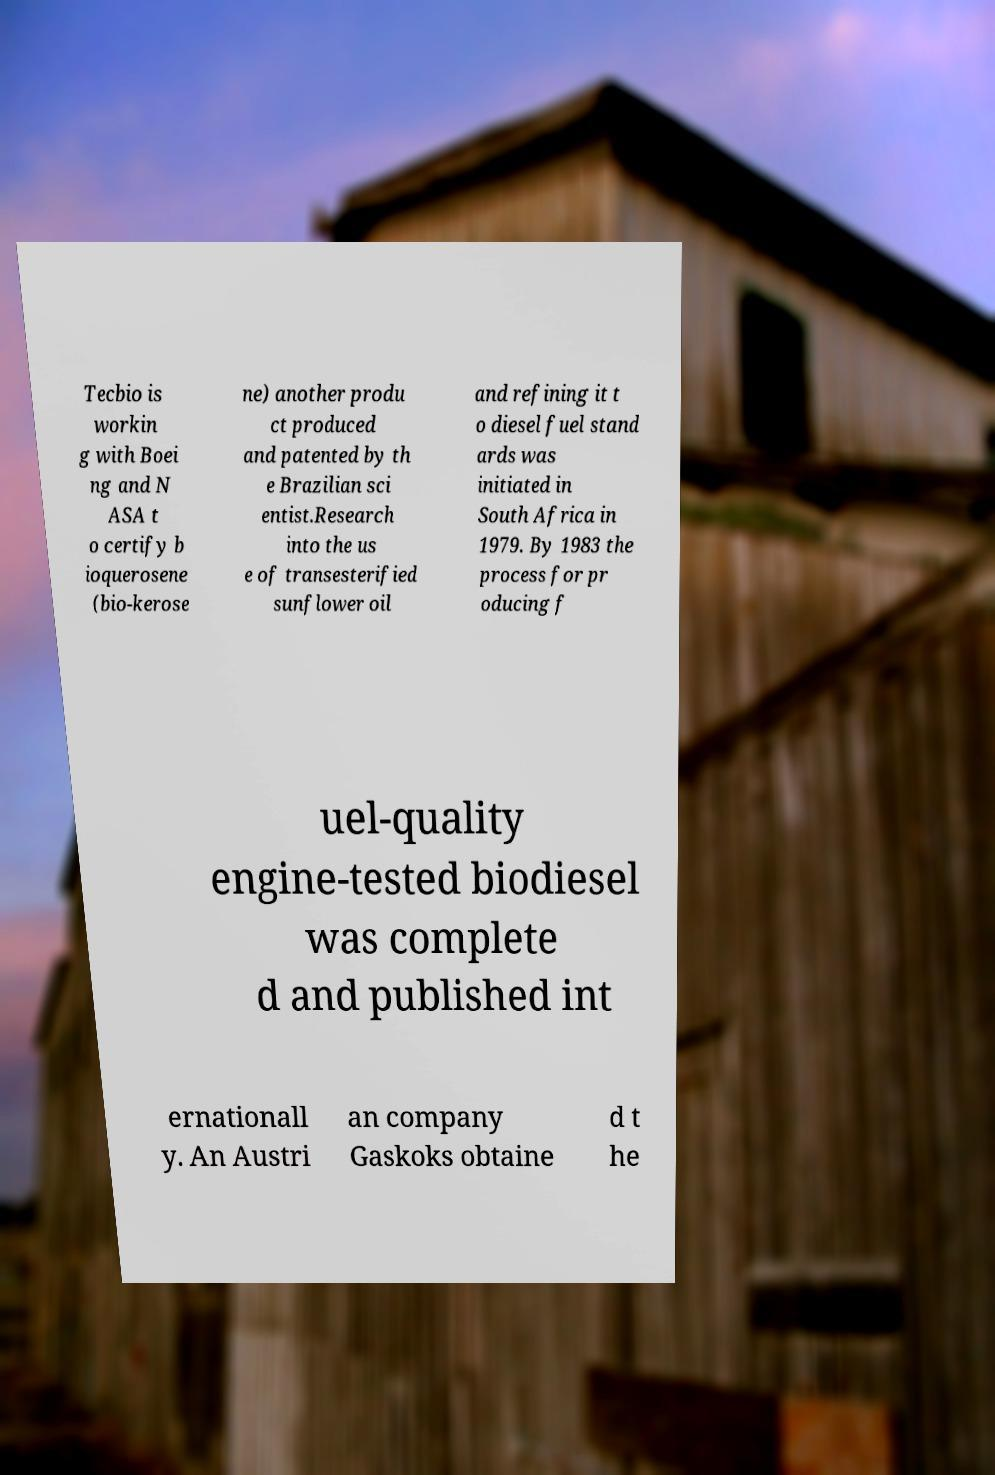I need the written content from this picture converted into text. Can you do that? Tecbio is workin g with Boei ng and N ASA t o certify b ioquerosene (bio-kerose ne) another produ ct produced and patented by th e Brazilian sci entist.Research into the us e of transesterified sunflower oil and refining it t o diesel fuel stand ards was initiated in South Africa in 1979. By 1983 the process for pr oducing f uel-quality engine-tested biodiesel was complete d and published int ernationall y. An Austri an company Gaskoks obtaine d t he 